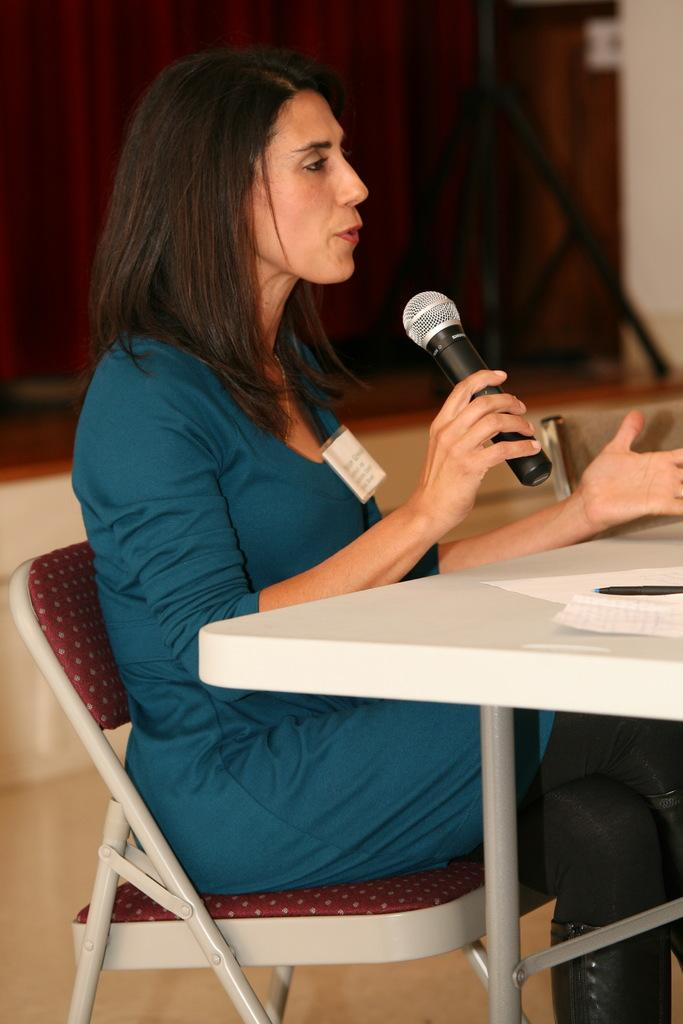Who is the main subject in the image? There is a woman in the image. What is the woman holding in the image? The woman is holding a microphone. What is the woman doing in the image? The woman is speaking. What is the woman's position in the image? The woman is seated on a chair. What other object can be seen in the image? There is a table in the image. Can you see a hill in the background of the image? There is no hill visible in the background of the image. 